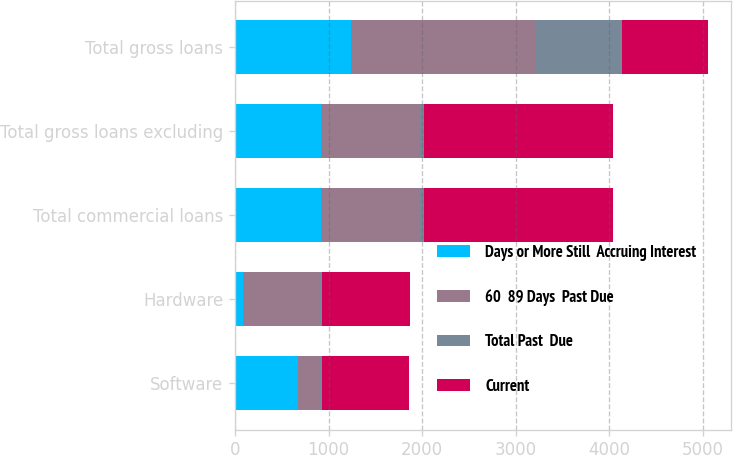<chart> <loc_0><loc_0><loc_500><loc_500><stacked_bar_chart><ecel><fcel>Software<fcel>Hardware<fcel>Total commercial loans<fcel>Total gross loans excluding<fcel>Total gross loans<nl><fcel>Days or More Still  Accruing Interest<fcel>674<fcel>89<fcel>920<fcel>920<fcel>1243<nl><fcel>60  89 Days  Past Due<fcel>239<fcel>819<fcel>1058<fcel>1058<fcel>1971<nl><fcel>Total Past  Due<fcel>17<fcel>27<fcel>44<fcel>44<fcel>920<nl><fcel>Current<fcel>930<fcel>935<fcel>2022<fcel>2022<fcel>920<nl></chart> 